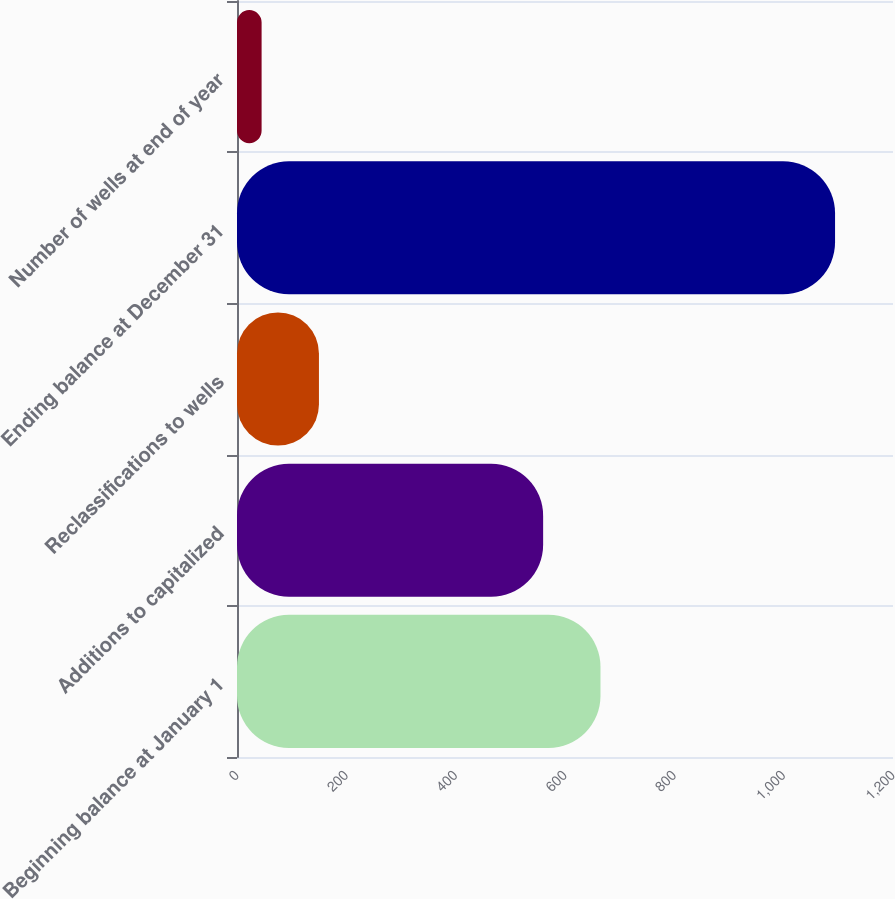<chart> <loc_0><loc_0><loc_500><loc_500><bar_chart><fcel>Beginning balance at January 1<fcel>Additions to capitalized<fcel>Reclassifications to wells<fcel>Ending balance at December 31<fcel>Number of wells at end of year<nl><fcel>664.9<fcel>560<fcel>149.9<fcel>1094<fcel>45<nl></chart> 